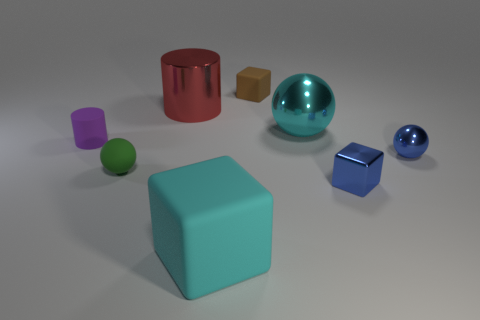Add 2 matte cylinders. How many objects exist? 10 Subtract all small balls. How many balls are left? 1 Subtract all spheres. How many objects are left? 5 Subtract all brown balls. Subtract all green cylinders. How many balls are left? 3 Subtract all brown rubber cylinders. Subtract all tiny blue objects. How many objects are left? 6 Add 3 big metal objects. How many big metal objects are left? 5 Add 6 large yellow cylinders. How many large yellow cylinders exist? 6 Subtract 0 yellow cubes. How many objects are left? 8 